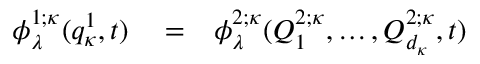<formula> <loc_0><loc_0><loc_500><loc_500>\begin{array} { r l r } { \phi _ { \lambda } ^ { 1 ; \kappa } ( q _ { \kappa } ^ { 1 } , t ) } & = } & { \phi _ { \lambda } ^ { 2 ; \kappa } ( Q _ { 1 } ^ { 2 ; \kappa } , \dots , Q _ { d _ { \kappa } } ^ { 2 ; \kappa } , t ) } \end{array}</formula> 